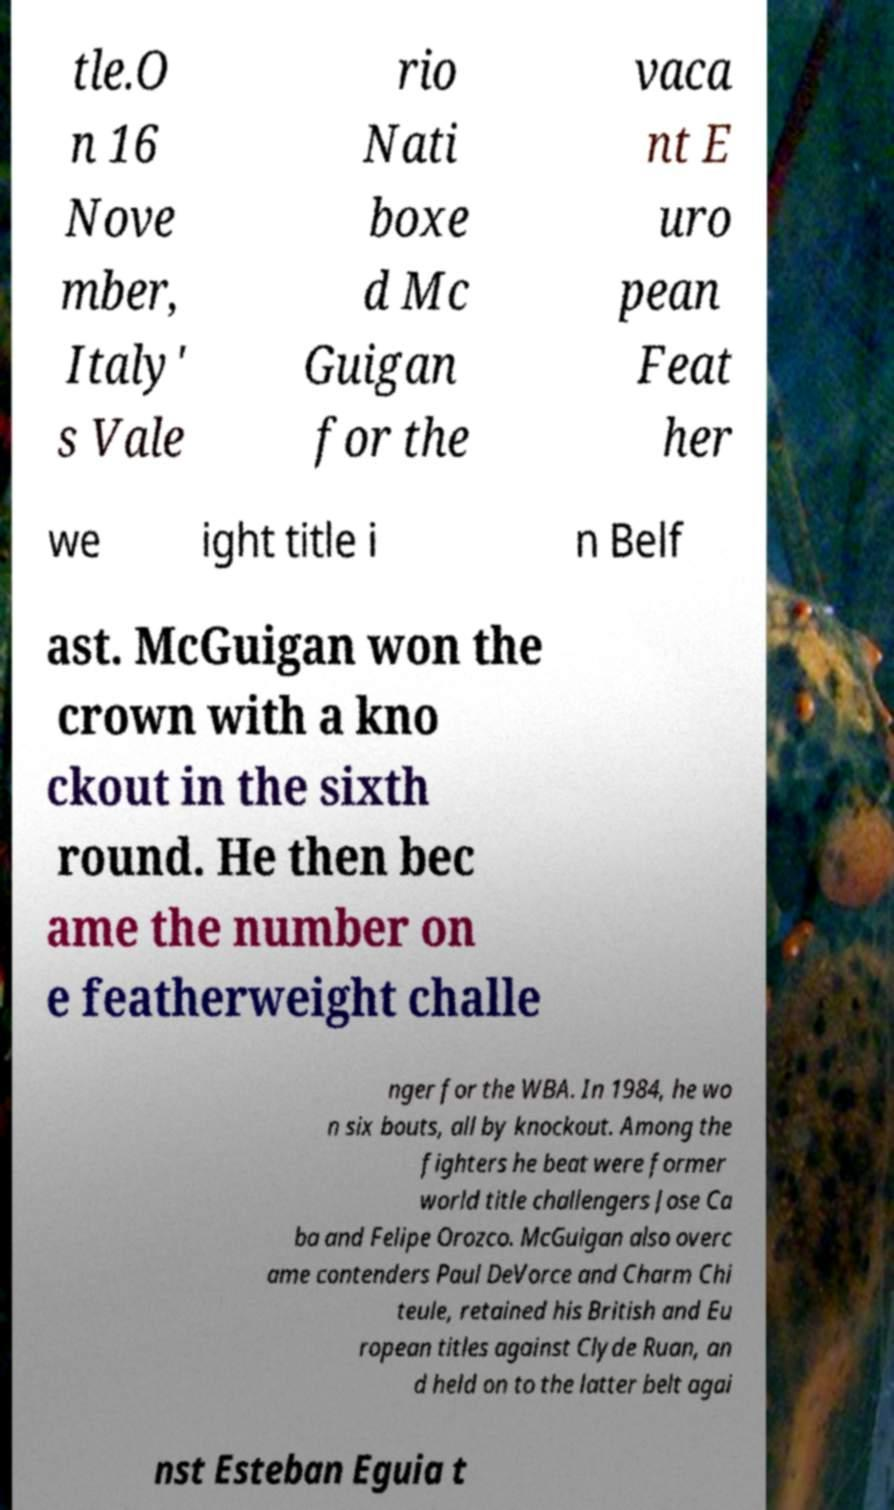Can you accurately transcribe the text from the provided image for me? tle.O n 16 Nove mber, Italy' s Vale rio Nati boxe d Mc Guigan for the vaca nt E uro pean Feat her we ight title i n Belf ast. McGuigan won the crown with a kno ckout in the sixth round. He then bec ame the number on e featherweight challe nger for the WBA. In 1984, he wo n six bouts, all by knockout. Among the fighters he beat were former world title challengers Jose Ca ba and Felipe Orozco. McGuigan also overc ame contenders Paul DeVorce and Charm Chi teule, retained his British and Eu ropean titles against Clyde Ruan, an d held on to the latter belt agai nst Esteban Eguia t 